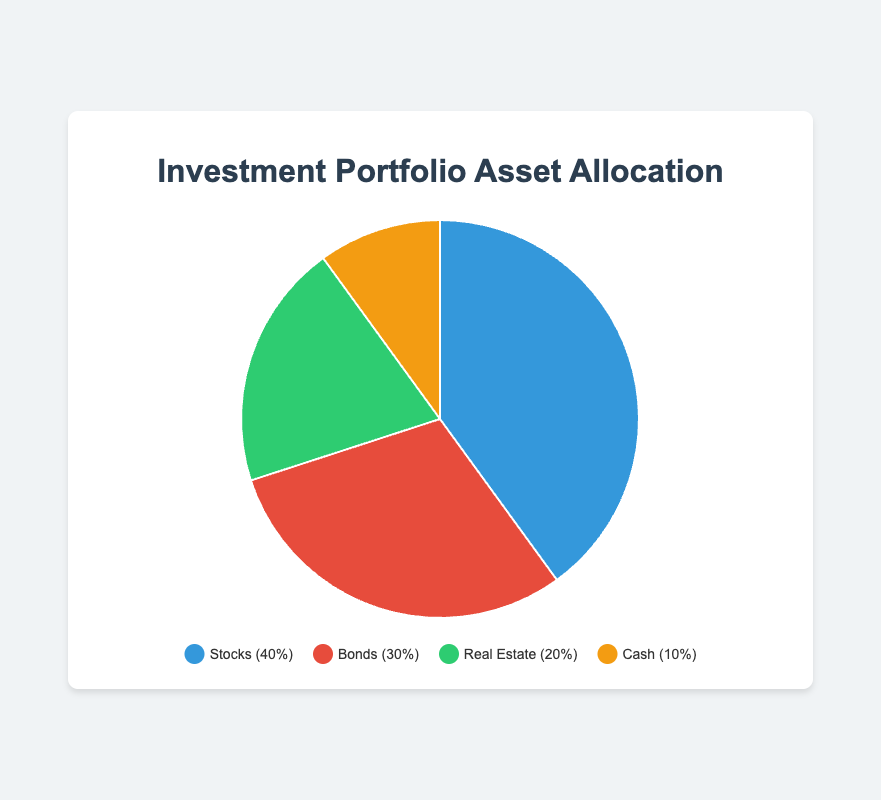what is the most heavily allocated asset in the portfolio? The pie chart shows the allocation percentages for each asset type. The largest segment of the pie chart is for Stocks, which is 40%.
Answer: Stocks compare the allocation percentages of stocks and bonds. Which one is greater and by how much? The allocation percentage for Stocks is 40% and for Bonds is 30%. To find the difference, subtract the smaller percentage from the larger one: 40% - 30% = 10%.
Answer: Stocks by 10% what is the total allocation percentage of stocks and real estate combined? The allocation for Stocks is 40% and for Real Estate is 20%. Add these together: 40% + 20% = 60%.
Answer: 60% which asset has the smallest allocation percentage, and what is it? By inspecting the pie chart, the smallest segment is for Cash, with an allocation of 10%.
Answer: Cash, 10% how do the combined allocations of bonds and real estate compare to the allocation of stocks? The allocation for Bonds is 30% and for Real Estate is 20%. Their combined allocation is 30% + 20% = 50%. This is compared to 40% for Stocks.
Answer: Combined 50% is greater what is the color of the segment representing cash? By reviewing the legend, the segment representing Cash is associated with the color orange.
Answer: Orange what is the average allocation percentage of the four asset types? The individual allocation percentages are 40%, 30%, 20%, and 10%. Adding them gives 100%. There are 4 asset types, so the average is 100% / 4 = 25%.
Answer: 25% how much greater is the stocks allocation compared to the cash allocation? The allocation for Stocks is 40% and for Cash is 10%. Subtract the smaller percentage from the larger one: 40% - 10% = 30%.
Answer: 30% what is the sum of the allocations for bonds and cash? The allocation for Bonds is 30% and for Cash is 10%. Adding them gives 30% + 10% = 40%.
Answer: 40% describe the visual difference between the segments for stocks and real estate. The segment for Stocks is larger than the Real Estate segment. Stocks is colored blue and takes up 40% of the chart, while Real Estate is green and takes up 20%.
Answer: Stocks is larger and blue, Real Estate is smaller and green 